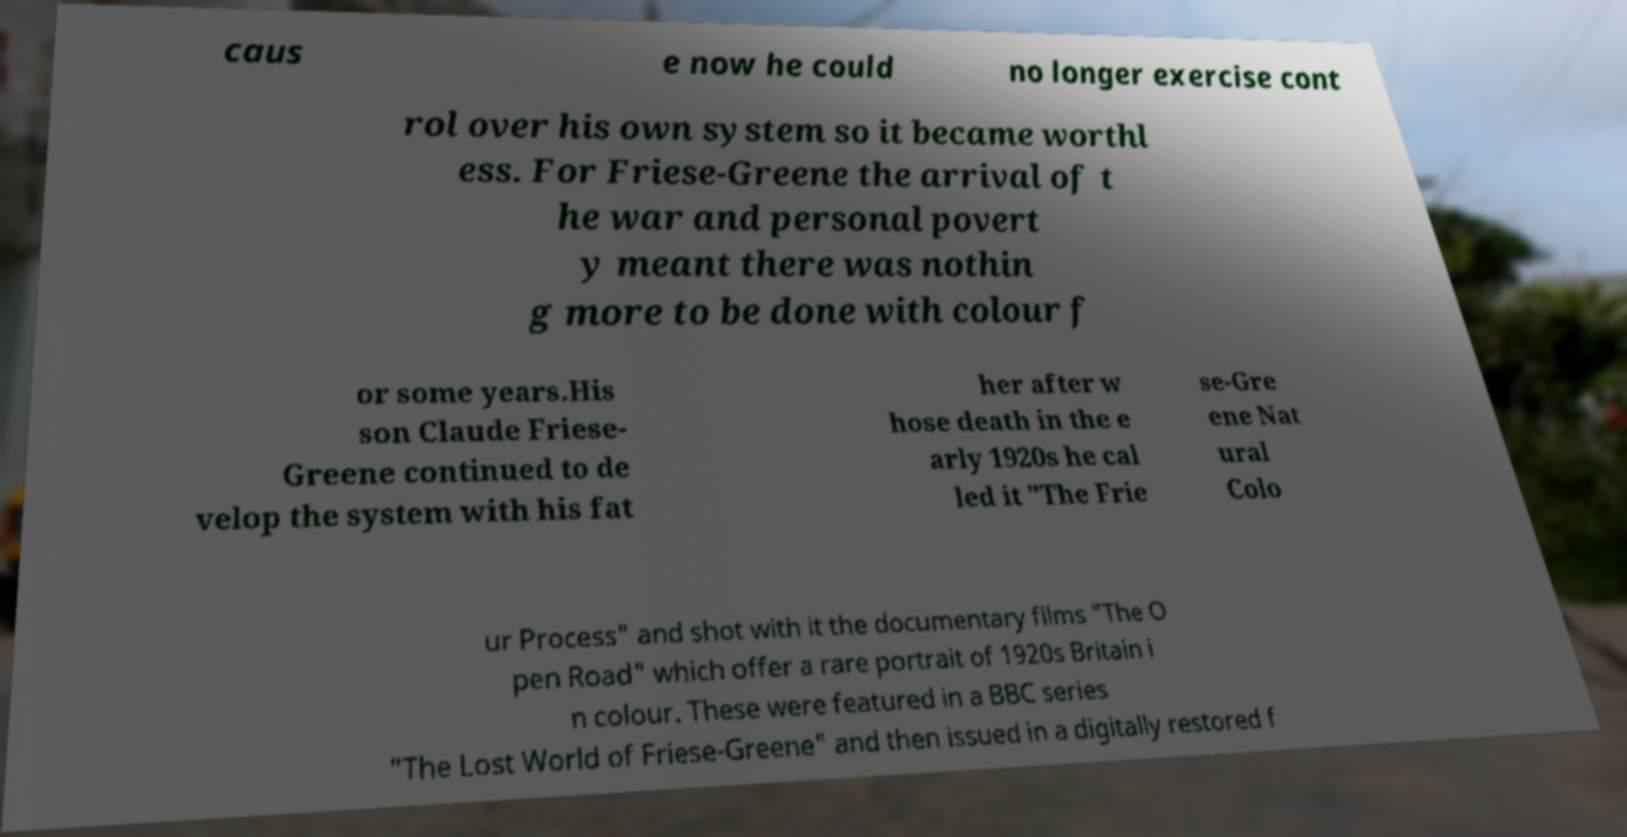What messages or text are displayed in this image? I need them in a readable, typed format. caus e now he could no longer exercise cont rol over his own system so it became worthl ess. For Friese-Greene the arrival of t he war and personal povert y meant there was nothin g more to be done with colour f or some years.His son Claude Friese- Greene continued to de velop the system with his fat her after w hose death in the e arly 1920s he cal led it "The Frie se-Gre ene Nat ural Colo ur Process" and shot with it the documentary films "The O pen Road" which offer a rare portrait of 1920s Britain i n colour. These were featured in a BBC series "The Lost World of Friese-Greene" and then issued in a digitally restored f 